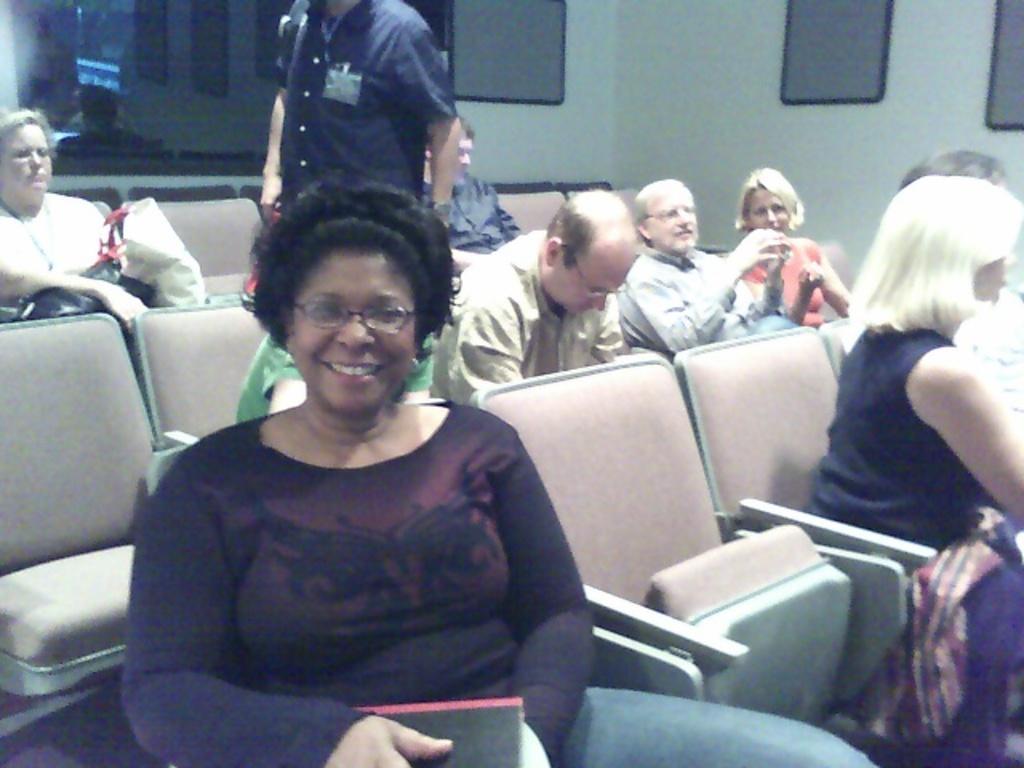In one or two sentences, can you explain what this image depicts? In this image we can see some people sitting in the chairs. And we can see the glass window. And we can see some frames on the wall. 